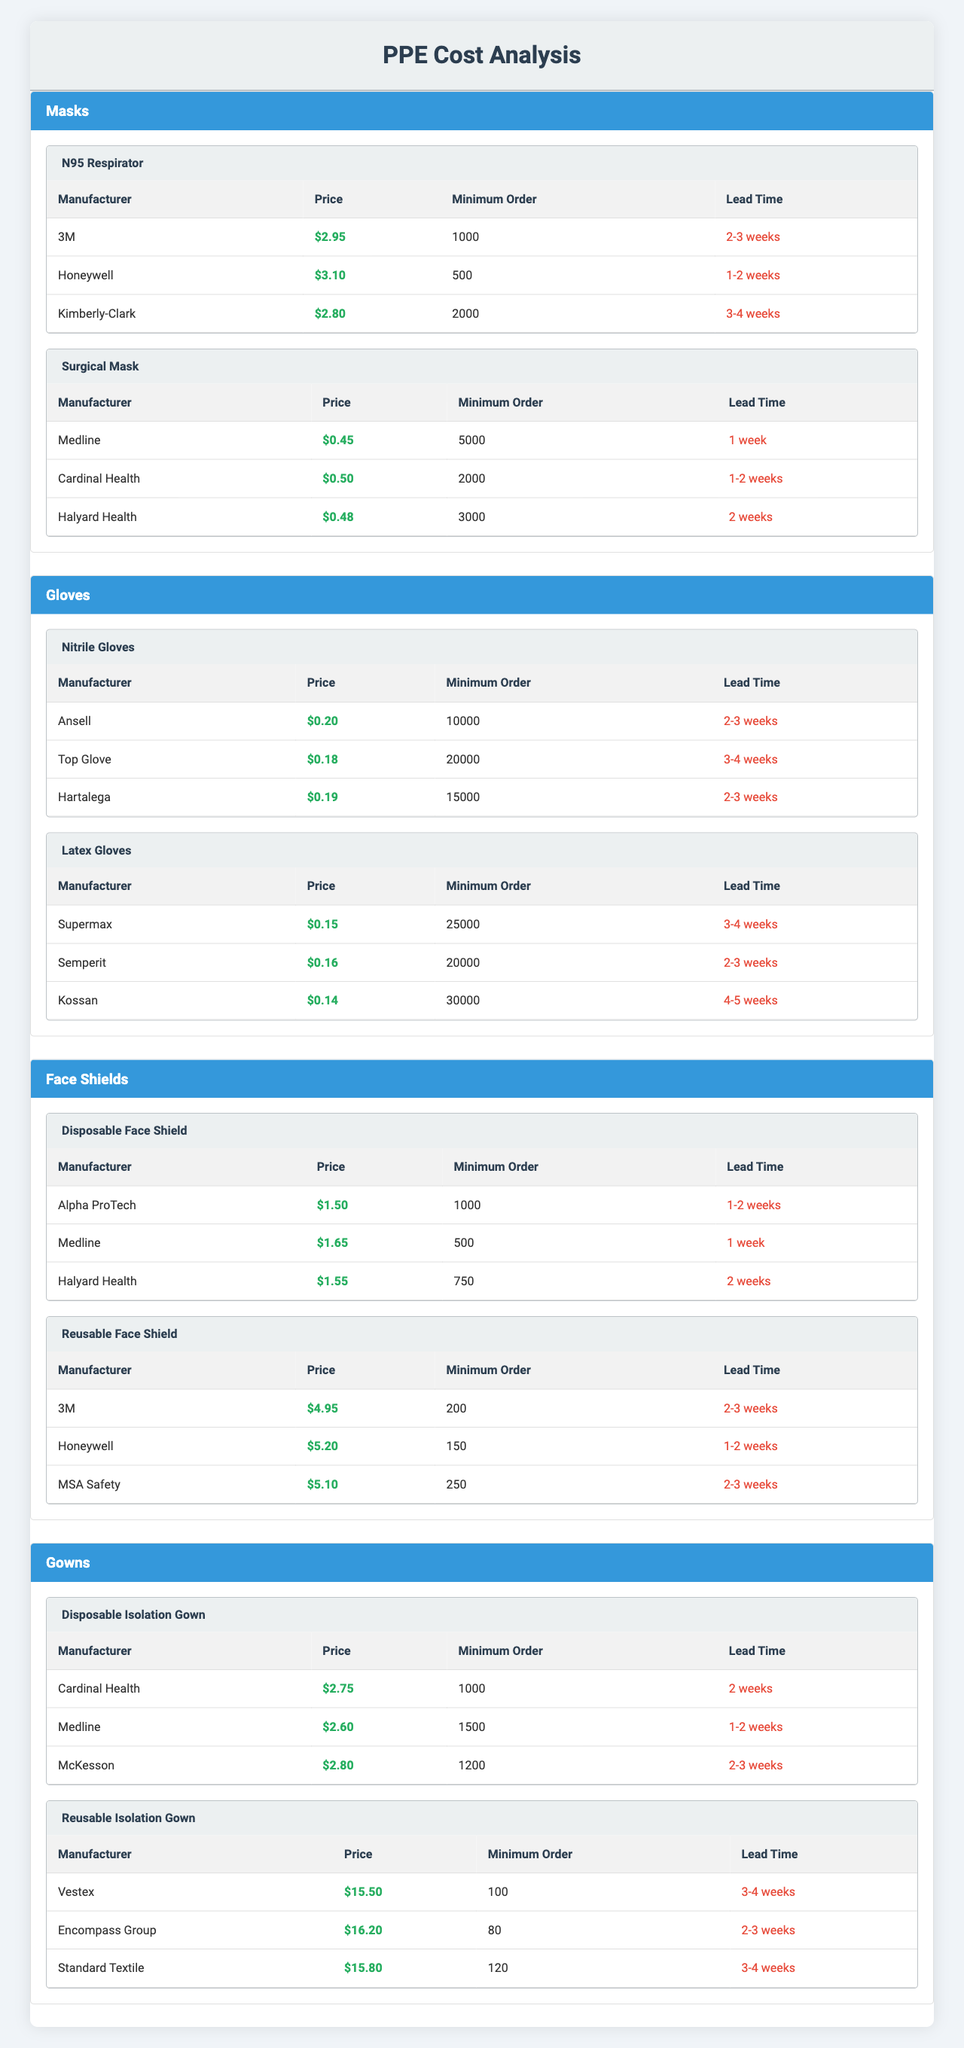What is the price of the N95 Respirator from Kimberly-Clark? The table shows that the price of the N95 Respirator from Kimberly-Clark is $2.80.
Answer: $2.80 Which manufacturer offers the lowest price for Latex Gloves? According to the table, Kossan offers the lowest price for Latex Gloves at $0.14.
Answer: Kossan What is the minimum order quantity for Disposable Isolation Gowns from Medline? The table indicates that the minimum order quantity for Disposable Isolation Gowns from Medline is 1500.
Answer: 1500 How much would 10,000 Surgical Masks cost from Medline? The price per Surgical Mask from Medline is $0.45, so for 10,000, it would cost 10,000 * $0.45 = $4,500.
Answer: $4,500 Which item has the longest lead time between Disposable Face Shield and Reusable Face Shield? The table shows that both Disposable Face Shield and Reusable Face Shield have a lead time of 2-3 weeks. Therefore, neither has a longer lead time; they are the same.
Answer: Neither; they are the same What is the average price of the Nitrile Gloves offered by the three manufacturers? The prices are $0.20 (Ansell), $0.18 (Top Glove), and $0.19 (Hartalega). The average is (0.20 + 0.18 + 0.19) / 3 = $0.19.
Answer: $0.19 Is the minimum order for the Reusable Isolation Gown higher than 100? The table states the minimum order for the Reusable Isolation Gown (Vestex) is 100. Since it is equal, the answer is No.
Answer: No What is the total minimum order quantity required if an order is placed for one type of gloves and one type of mask? For gloves, the highest minimum order quantity is 20,000 from Top Glove and for masks, it’s 2,000 from Kimberly-Clark. The total minimum order is 20,000 + 2,000 = 22,000.
Answer: 22,000 Which Face Shield has the shortest lead time? The Disposable Face Shield from Medline has the shortest lead time of 1 week, compared to the other options.
Answer: Disposable Face Shield from Medline What is the price difference between the Disposable Isolation Gown from Cardinal Health and the Reusable Isolation Gown from Vestex? The Disposable Isolation Gown costs $2.75, and the Reusable Isolation Gown costs $15.50. The price difference is $15.50 - $2.75 = $12.75.
Answer: $12.75 